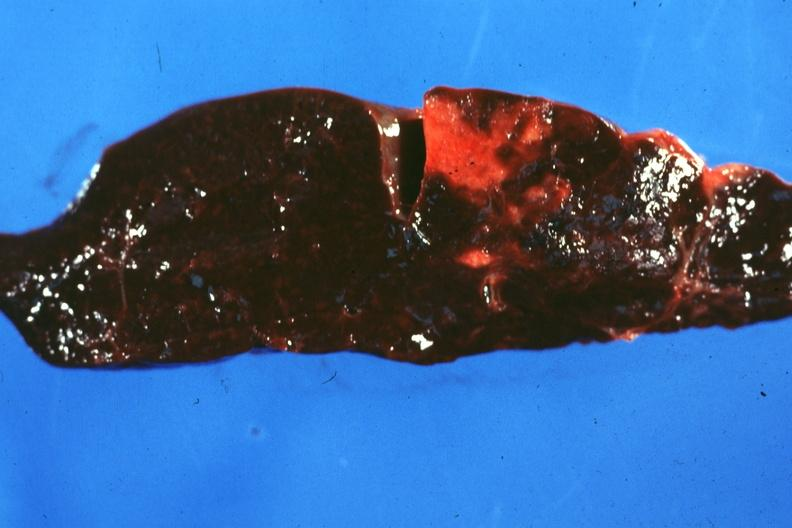where is this part in?
Answer the question using a single word or phrase. Spleen 